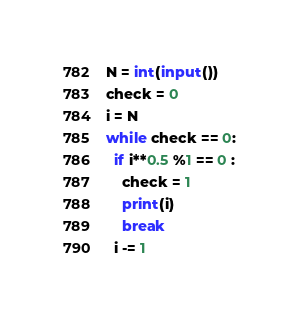Convert code to text. <code><loc_0><loc_0><loc_500><loc_500><_Python_>N = int(input())
check = 0
i = N
while check == 0:
  if i**0.5 %1 == 0 :
    check = 1
    print(i)
    break
  i -= 1</code> 